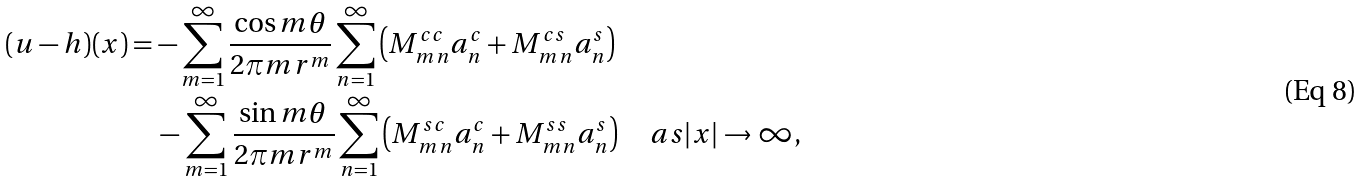Convert formula to latex. <formula><loc_0><loc_0><loc_500><loc_500>( u - h ) ( x ) & = - \sum _ { m = 1 } ^ { \infty } \frac { \cos m \theta } { 2 \pi m r ^ { m } } \sum _ { n = 1 } ^ { \infty } \left ( M _ { m n } ^ { c c } a _ { n } ^ { c } + M _ { m n } ^ { c s } a _ { n } ^ { s } \right ) \\ & \quad - \sum _ { m = 1 } ^ { \infty } \frac { \sin m \theta } { 2 \pi m r ^ { m } } \sum _ { n = 1 } ^ { \infty } \left ( M _ { m n } ^ { s c } a _ { n } ^ { c } + M _ { m n } ^ { s s } a _ { n } ^ { s } \right ) \quad a s | x | \to \infty ,</formula> 